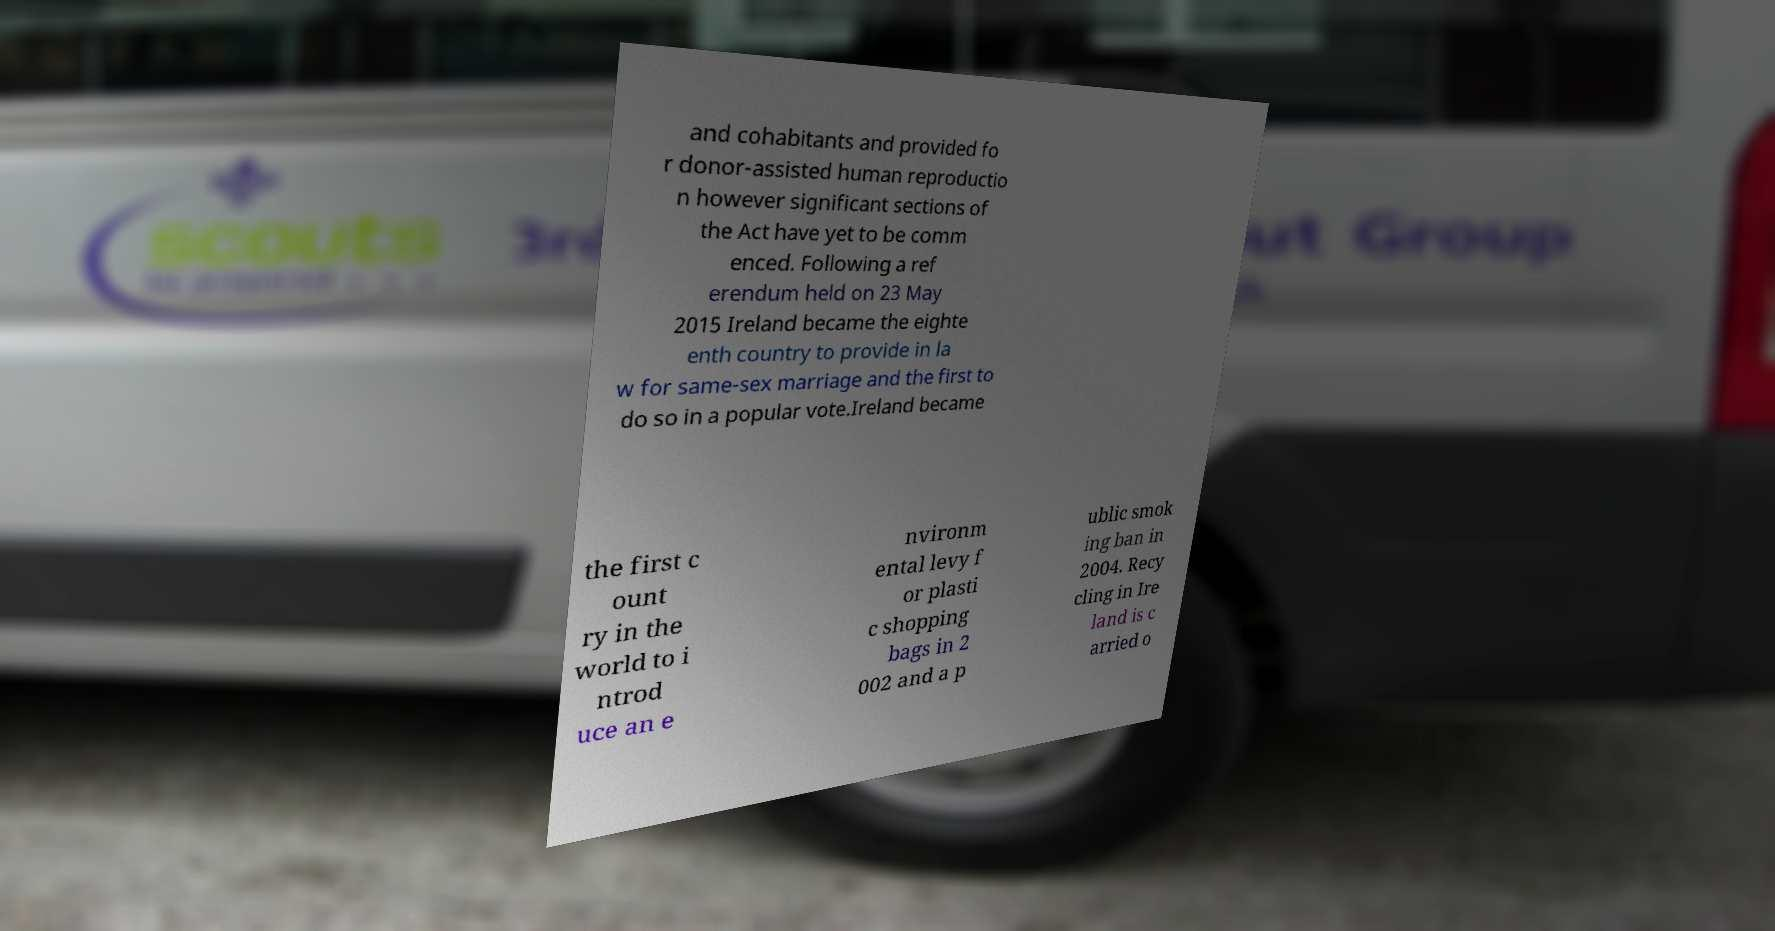Can you read and provide the text displayed in the image?This photo seems to have some interesting text. Can you extract and type it out for me? and cohabitants and provided fo r donor-assisted human reproductio n however significant sections of the Act have yet to be comm enced. Following a ref erendum held on 23 May 2015 Ireland became the eighte enth country to provide in la w for same-sex marriage and the first to do so in a popular vote.Ireland became the first c ount ry in the world to i ntrod uce an e nvironm ental levy f or plasti c shopping bags in 2 002 and a p ublic smok ing ban in 2004. Recy cling in Ire land is c arried o 